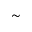<formula> <loc_0><loc_0><loc_500><loc_500>{ \sim }</formula> 